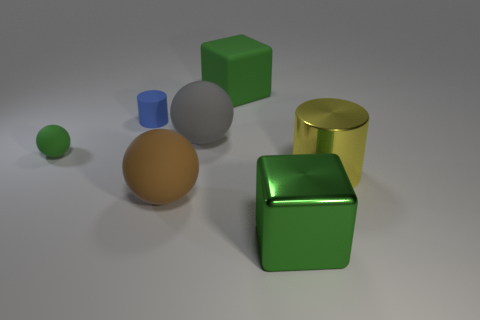There is a large matte ball that is behind the yellow metallic cylinder; what color is it? The large matte ball located behind the yellow metallic cylinder appears to be a shade of brown. Its matte finish gives it a non-reflective surface, contrasting with the shiny metallic surfaces of the objects in the foreground. 